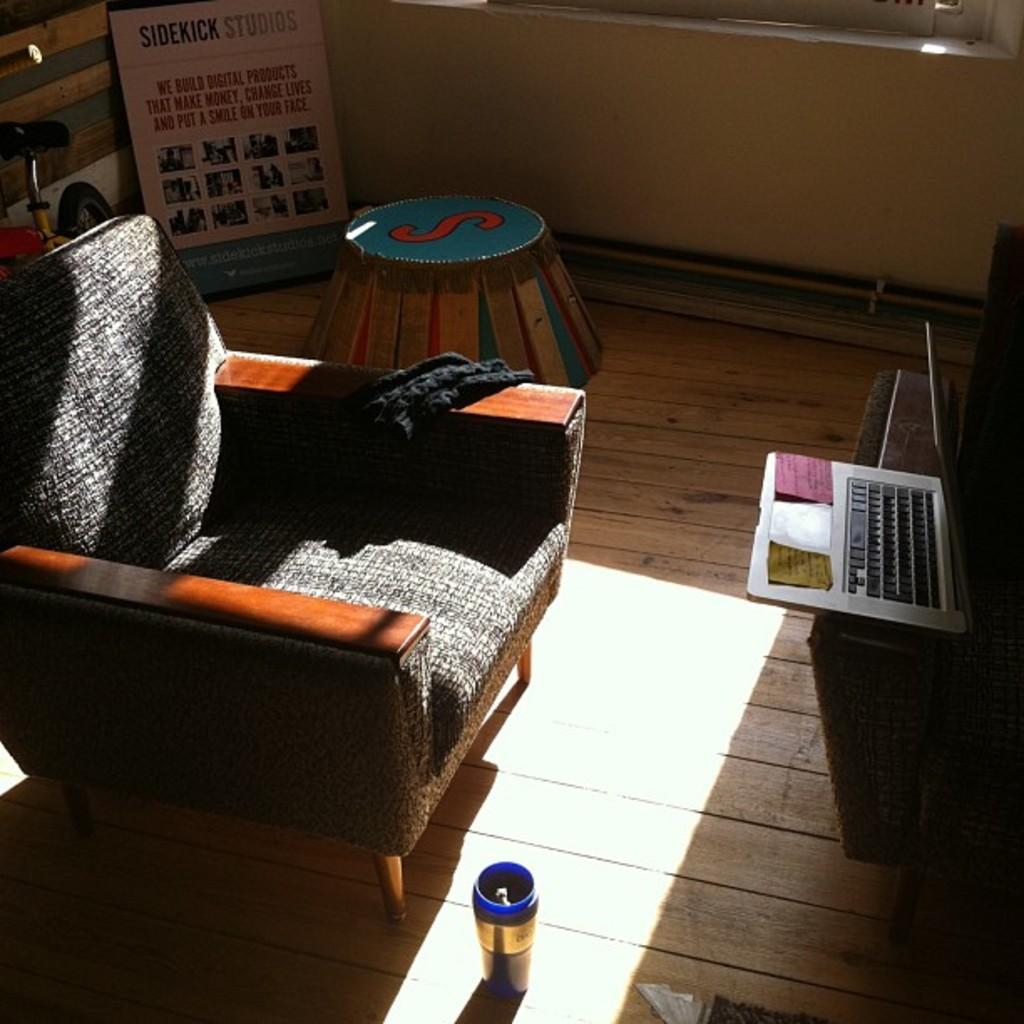Please provide a concise description of this image. There is a chair,laptop on table and bicycle in a room. 